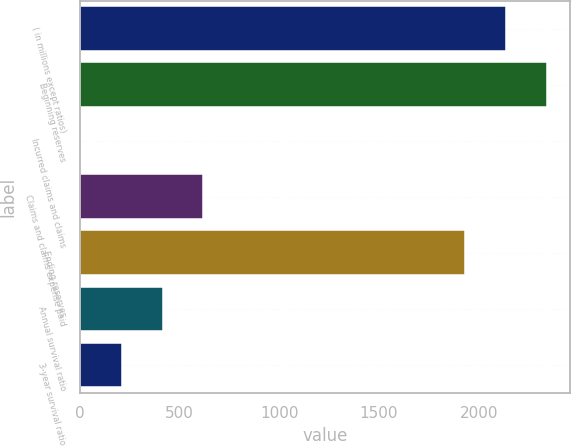Convert chart. <chart><loc_0><loc_0><loc_500><loc_500><bar_chart><fcel>( in millions except ratios)<fcel>Beginning reserves<fcel>Incurred claims and claims<fcel>Claims and claims expense paid<fcel>Ending reserves<fcel>Annual survival ratio<fcel>3-year survival ratio<nl><fcel>2137.9<fcel>2342.8<fcel>4<fcel>618.7<fcel>1933<fcel>413.8<fcel>208.9<nl></chart> 